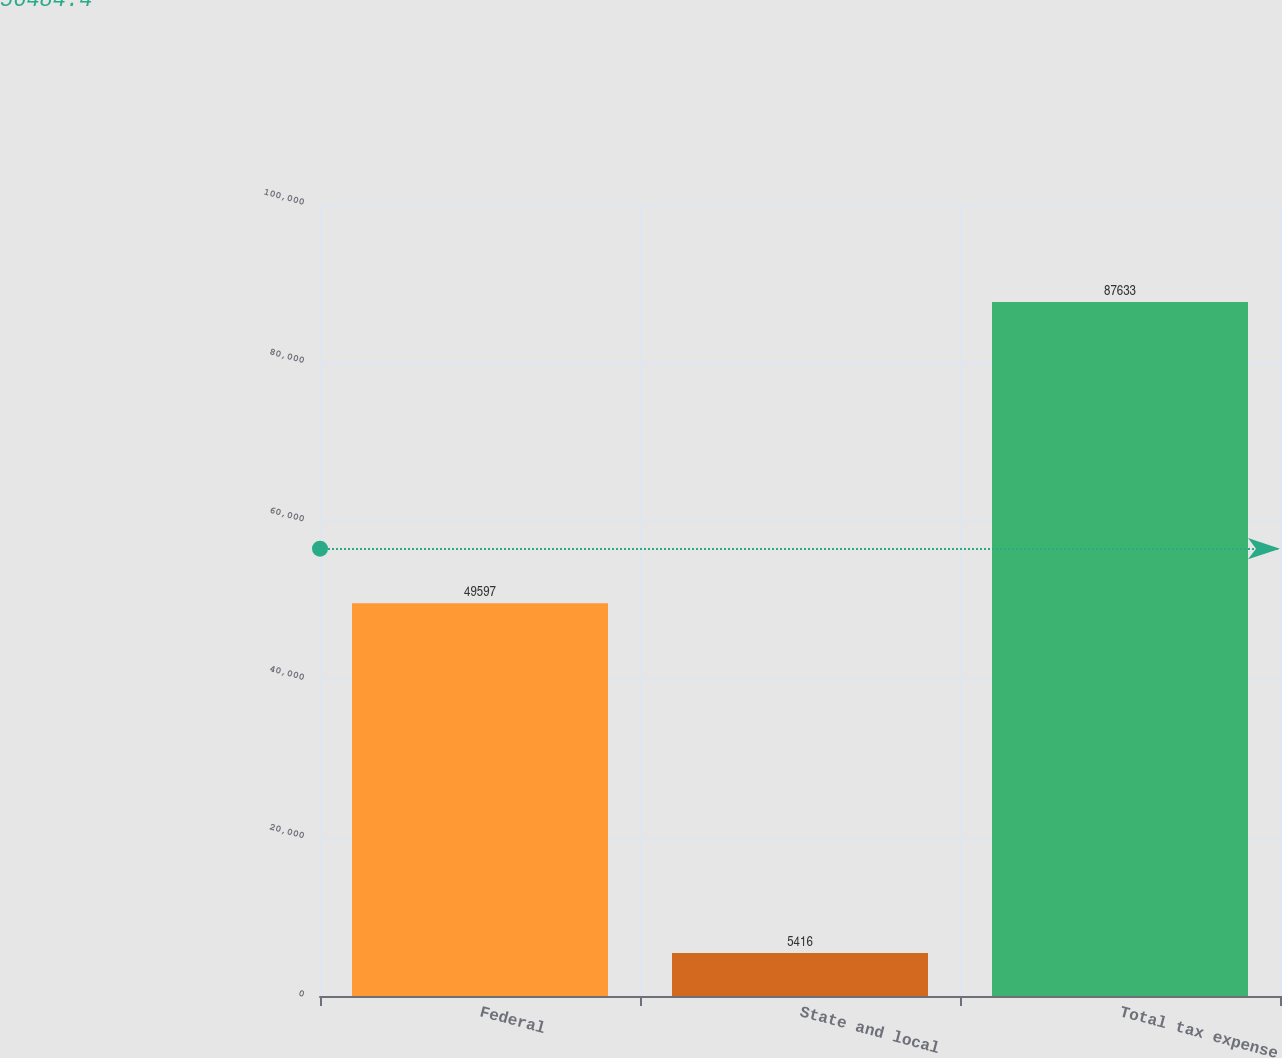Convert chart to OTSL. <chart><loc_0><loc_0><loc_500><loc_500><bar_chart><fcel>Federal<fcel>State and local<fcel>Total tax expense<nl><fcel>49597<fcel>5416<fcel>87633<nl></chart> 